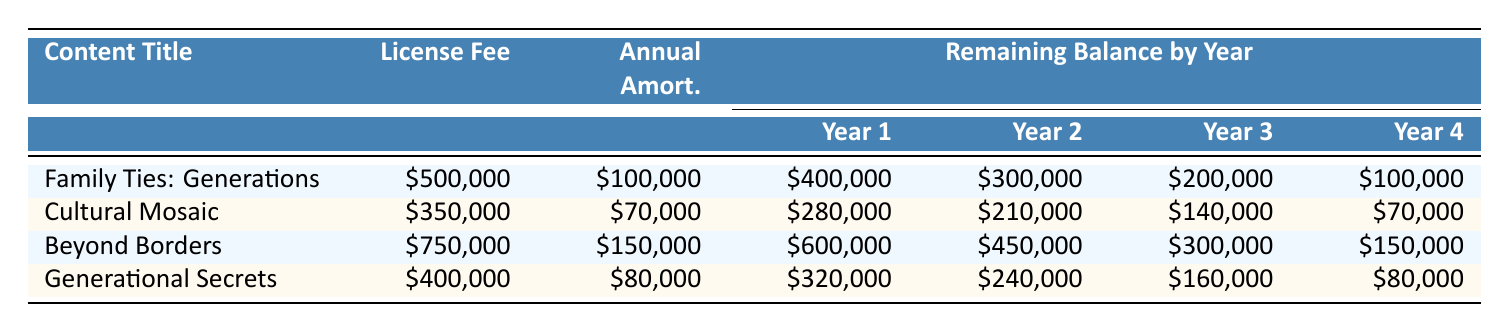What is the license fee for "Cultural Mosaic"? The license fee for "Cultural Mosaic" is listed directly in the table under the "License Fee" column. It shows \$350,000 as the value.
Answer: 350000 How much is the annual amortization for "Beyond Borders"? The annual amortization for "Beyond Borders" is provided in the "Annual Amort." column. The value is \$150,000.
Answer: 150000 Which content title has the highest remaining balance after Year 1? Comparing the remaining balances after Year 1 for all titles in the "Remaining Balance by Year" section, "Beyond Borders" has the highest remaining balance of \$600,000.
Answer: Beyond Borders What is the total license fee for all four programs? To find the total license fee, we sum the license fees of all titles: 500,000 + 350,000 + 750,000 + 400,000 = 2,000,000.
Answer: 2000000 Is "Family Ties: Generations" amortized by \$100,000 each year? Looking at the "Annual Amort." column for "Family Ties: Generations," it shows \$100,000, which confirms the amortization per year.
Answer: Yes What is the remaining balance for "Generational Secrets" in Year 3? The remaining balance for "Generational Secrets" in Year 3 is found in the corresponding row, which is \$160,000.
Answer: 160000 If we average the annual amortization amounts for all four titles, what is the result? The annual amortization amounts are 100,000, 70,000, 150,000, and 80,000. Summing these gives 400,000, and dividing by 4 (the number of titles) leads to an average of 100,000.
Answer: 100000 What is the remaining balance for "Cultural Mosaic" at the end of Year 2? The remaining balance for "Cultural Mosaic" at the end of Year 2 is \$210,000 as seen in the table under the "Remaining Balance by Year" section.
Answer: 210000 Which title has the lowest remaining balance at the end of Year 5? By examining the Year 5 values in the "Remaining Balance" section, we see that all titles have a remaining balance of \$0 at the end of Year 5. However, they are all equal, identifying no title specifically has a lower balance than another.
Answer: All titles 